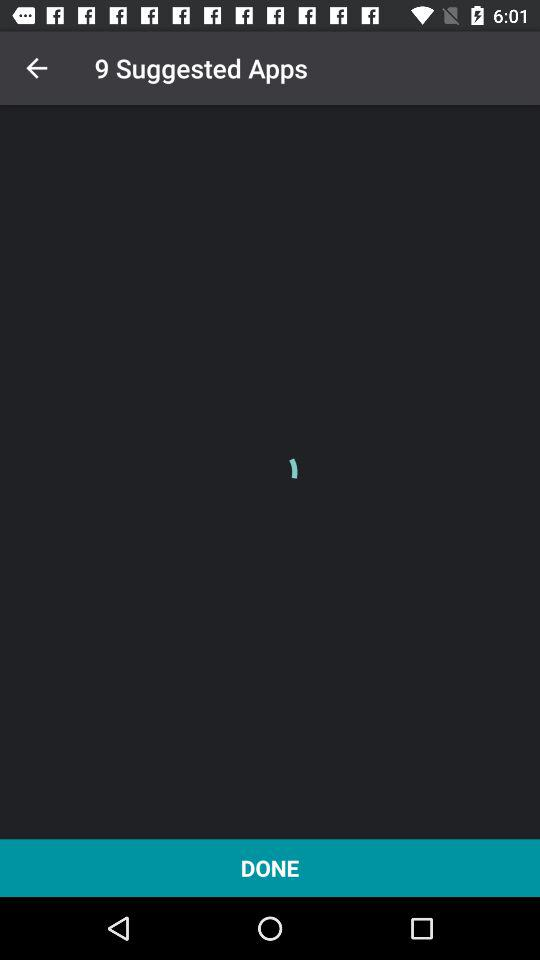What is the total number of suggested applications? The total number of suggested applications is 9. 